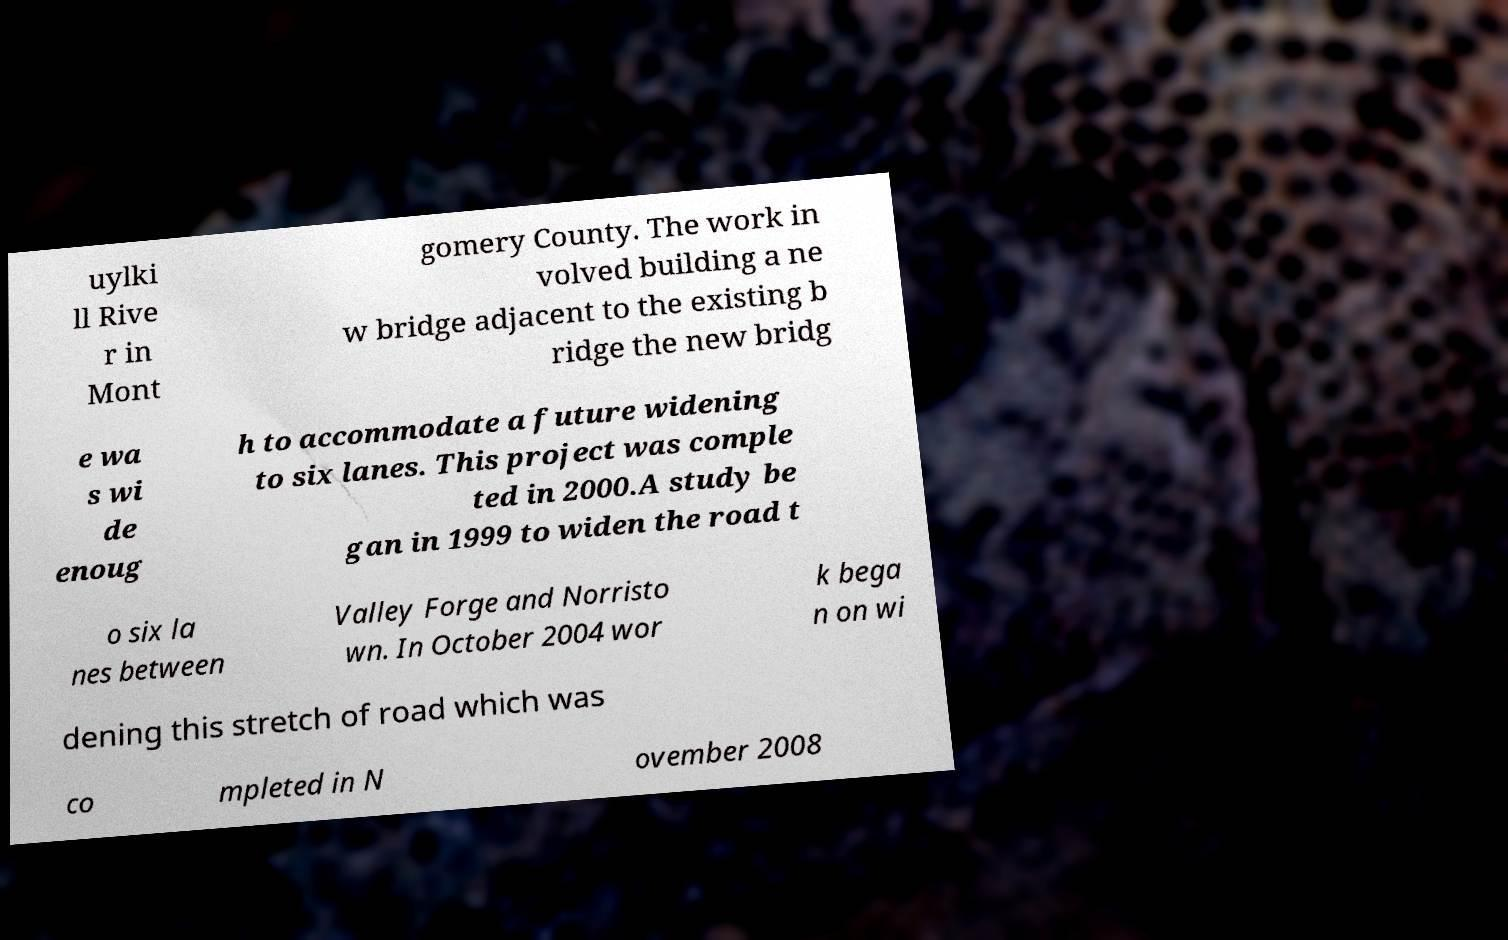Can you accurately transcribe the text from the provided image for me? uylki ll Rive r in Mont gomery County. The work in volved building a ne w bridge adjacent to the existing b ridge the new bridg e wa s wi de enoug h to accommodate a future widening to six lanes. This project was comple ted in 2000.A study be gan in 1999 to widen the road t o six la nes between Valley Forge and Norristo wn. In October 2004 wor k bega n on wi dening this stretch of road which was co mpleted in N ovember 2008 